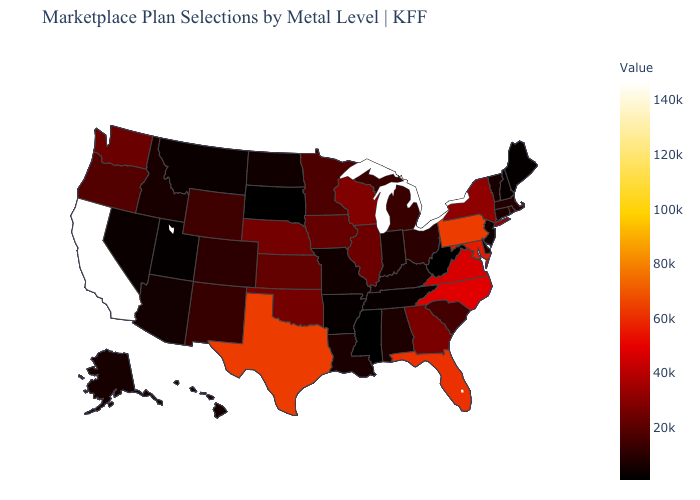Which states hav the highest value in the MidWest?
Quick response, please. Wisconsin. Which states have the lowest value in the Northeast?
Concise answer only. Maine. Does Mississippi have the lowest value in the USA?
Concise answer only. Yes. Among the states that border Alabama , which have the highest value?
Concise answer only. Florida. Does Pennsylvania have the highest value in the Northeast?
Answer briefly. Yes. Does Mississippi have the lowest value in the USA?
Concise answer only. Yes. 